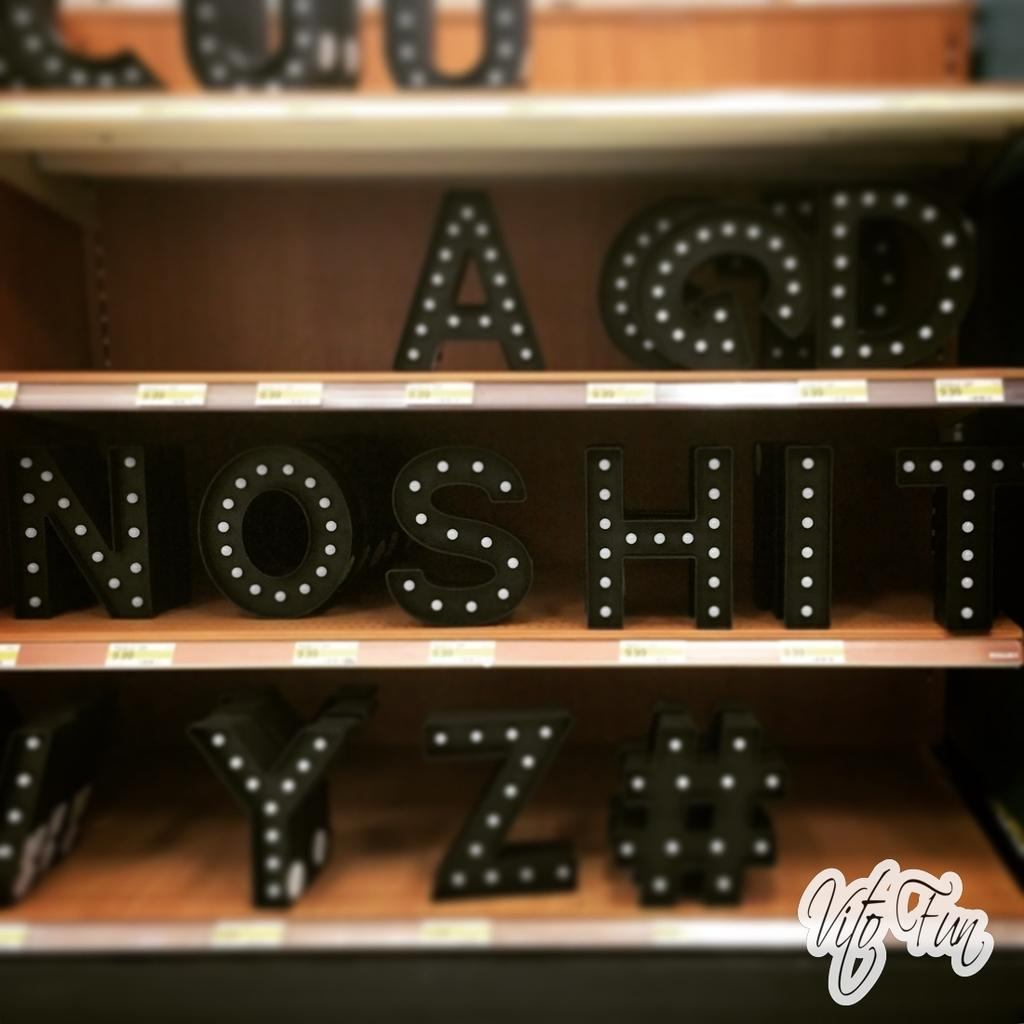What type of storage or display units are present in the image? There are shelves in the image. What can be found on the shelves? The shelves contain alphabets. Are there any additional decorations or markings on the shelves? Yes, there are stickers on the shelves. Is there any text visible in the image? Yes, there is text in the bottom right corner of the image. What beginner's club is being advertised in the image? There is no mention of a beginner's club or any advertisement in the image. 